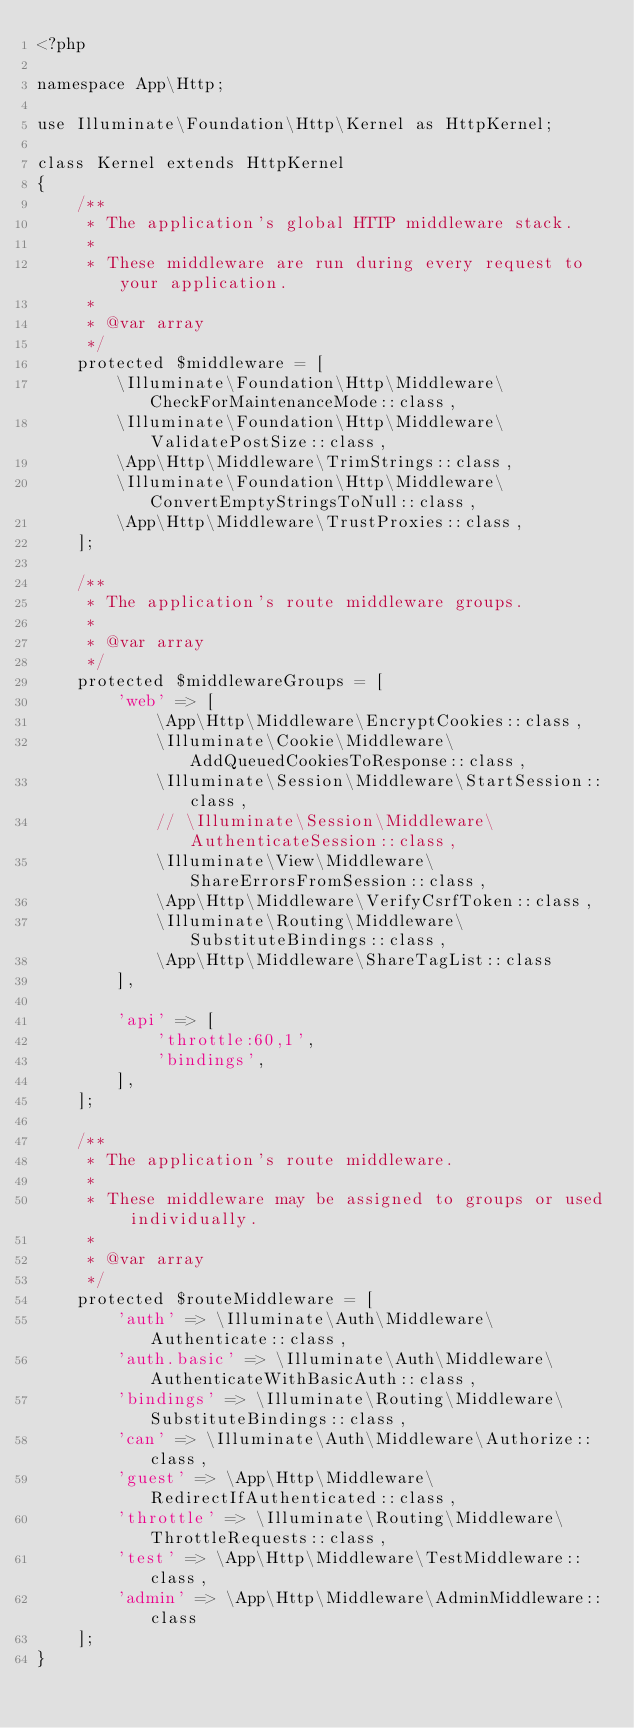<code> <loc_0><loc_0><loc_500><loc_500><_PHP_><?php

namespace App\Http;

use Illuminate\Foundation\Http\Kernel as HttpKernel;

class Kernel extends HttpKernel
{
    /**
     * The application's global HTTP middleware stack.
     *
     * These middleware are run during every request to your application.
     *
     * @var array
     */
    protected $middleware = [
        \Illuminate\Foundation\Http\Middleware\CheckForMaintenanceMode::class,
        \Illuminate\Foundation\Http\Middleware\ValidatePostSize::class,
        \App\Http\Middleware\TrimStrings::class,
        \Illuminate\Foundation\Http\Middleware\ConvertEmptyStringsToNull::class,
        \App\Http\Middleware\TrustProxies::class,
    ];

    /**
     * The application's route middleware groups.
     *
     * @var array
     */
    protected $middlewareGroups = [
        'web' => [
            \App\Http\Middleware\EncryptCookies::class,
            \Illuminate\Cookie\Middleware\AddQueuedCookiesToResponse::class,
            \Illuminate\Session\Middleware\StartSession::class,
            // \Illuminate\Session\Middleware\AuthenticateSession::class,
            \Illuminate\View\Middleware\ShareErrorsFromSession::class,
            \App\Http\Middleware\VerifyCsrfToken::class,
            \Illuminate\Routing\Middleware\SubstituteBindings::class,
            \App\Http\Middleware\ShareTagList::class
        ],

        'api' => [
            'throttle:60,1',
            'bindings',
        ],
    ];

    /**
     * The application's route middleware.
     *
     * These middleware may be assigned to groups or used individually.
     *
     * @var array
     */
    protected $routeMiddleware = [
        'auth' => \Illuminate\Auth\Middleware\Authenticate::class,
        'auth.basic' => \Illuminate\Auth\Middleware\AuthenticateWithBasicAuth::class,
        'bindings' => \Illuminate\Routing\Middleware\SubstituteBindings::class,
        'can' => \Illuminate\Auth\Middleware\Authorize::class,
        'guest' => \App\Http\Middleware\RedirectIfAuthenticated::class,
        'throttle' => \Illuminate\Routing\Middleware\ThrottleRequests::class,
        'test' => \App\Http\Middleware\TestMiddleware::class,
        'admin' => \App\Http\Middleware\AdminMiddleware::class
    ];
}
</code> 